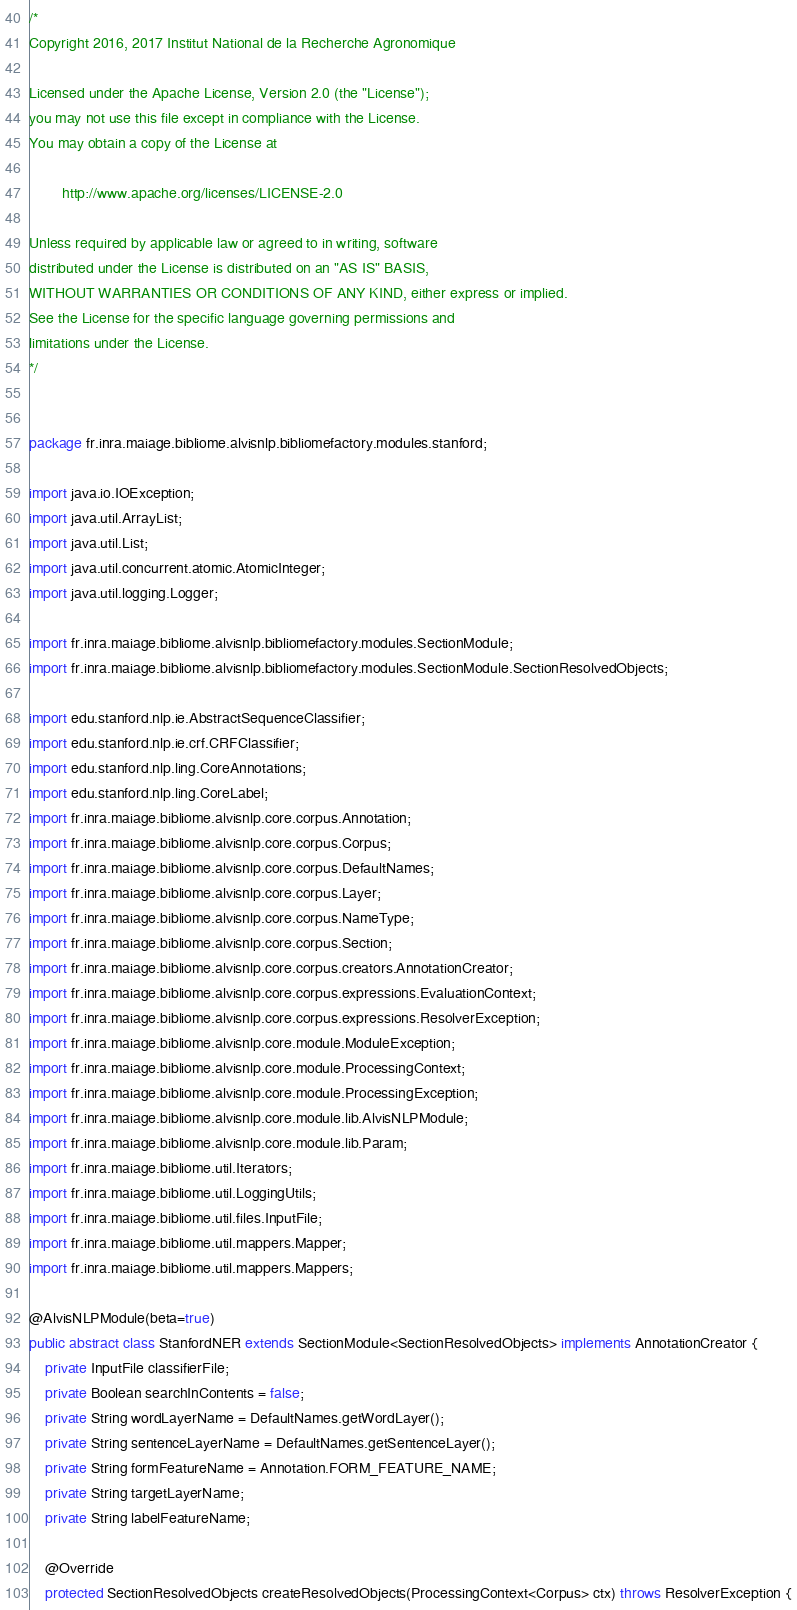Convert code to text. <code><loc_0><loc_0><loc_500><loc_500><_Java_>/*
Copyright 2016, 2017 Institut National de la Recherche Agronomique

Licensed under the Apache License, Version 2.0 (the "License");
you may not use this file except in compliance with the License.
You may obtain a copy of the License at

        http://www.apache.org/licenses/LICENSE-2.0

Unless required by applicable law or agreed to in writing, software
distributed under the License is distributed on an "AS IS" BASIS,
WITHOUT WARRANTIES OR CONDITIONS OF ANY KIND, either express or implied.
See the License for the specific language governing permissions and
limitations under the License.
*/


package fr.inra.maiage.bibliome.alvisnlp.bibliomefactory.modules.stanford;

import java.io.IOException;
import java.util.ArrayList;
import java.util.List;
import java.util.concurrent.atomic.AtomicInteger;
import java.util.logging.Logger;

import fr.inra.maiage.bibliome.alvisnlp.bibliomefactory.modules.SectionModule;
import fr.inra.maiage.bibliome.alvisnlp.bibliomefactory.modules.SectionModule.SectionResolvedObjects;

import edu.stanford.nlp.ie.AbstractSequenceClassifier;
import edu.stanford.nlp.ie.crf.CRFClassifier;
import edu.stanford.nlp.ling.CoreAnnotations;
import edu.stanford.nlp.ling.CoreLabel;
import fr.inra.maiage.bibliome.alvisnlp.core.corpus.Annotation;
import fr.inra.maiage.bibliome.alvisnlp.core.corpus.Corpus;
import fr.inra.maiage.bibliome.alvisnlp.core.corpus.DefaultNames;
import fr.inra.maiage.bibliome.alvisnlp.core.corpus.Layer;
import fr.inra.maiage.bibliome.alvisnlp.core.corpus.NameType;
import fr.inra.maiage.bibliome.alvisnlp.core.corpus.Section;
import fr.inra.maiage.bibliome.alvisnlp.core.corpus.creators.AnnotationCreator;
import fr.inra.maiage.bibliome.alvisnlp.core.corpus.expressions.EvaluationContext;
import fr.inra.maiage.bibliome.alvisnlp.core.corpus.expressions.ResolverException;
import fr.inra.maiage.bibliome.alvisnlp.core.module.ModuleException;
import fr.inra.maiage.bibliome.alvisnlp.core.module.ProcessingContext;
import fr.inra.maiage.bibliome.alvisnlp.core.module.ProcessingException;
import fr.inra.maiage.bibliome.alvisnlp.core.module.lib.AlvisNLPModule;
import fr.inra.maiage.bibliome.alvisnlp.core.module.lib.Param;
import fr.inra.maiage.bibliome.util.Iterators;
import fr.inra.maiage.bibliome.util.LoggingUtils;
import fr.inra.maiage.bibliome.util.files.InputFile;
import fr.inra.maiage.bibliome.util.mappers.Mapper;
import fr.inra.maiage.bibliome.util.mappers.Mappers;

@AlvisNLPModule(beta=true)
public abstract class StanfordNER extends SectionModule<SectionResolvedObjects> implements AnnotationCreator {
	private InputFile classifierFile;
	private Boolean searchInContents = false;
	private String wordLayerName = DefaultNames.getWordLayer();
	private String sentenceLayerName = DefaultNames.getSentenceLayer();
	private String formFeatureName = Annotation.FORM_FEATURE_NAME;
	private String targetLayerName;
	private String labelFeatureName;
	
	@Override
	protected SectionResolvedObjects createResolvedObjects(ProcessingContext<Corpus> ctx) throws ResolverException {</code> 